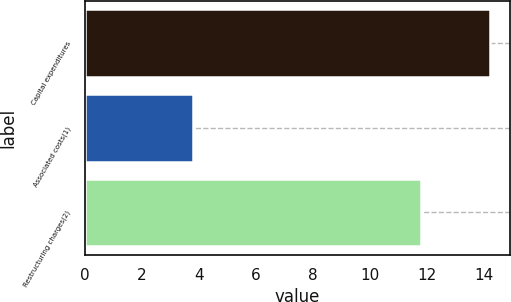Convert chart. <chart><loc_0><loc_0><loc_500><loc_500><bar_chart><fcel>Capital expenditures<fcel>Associated costs(1)<fcel>Restructuring charges(2)<nl><fcel>14.2<fcel>3.8<fcel>11.8<nl></chart> 